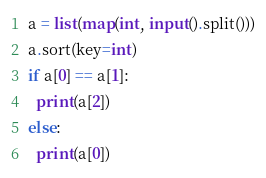<code> <loc_0><loc_0><loc_500><loc_500><_Python_>a = list(map(int, input().split()))
a.sort(key=int)
if a[0] == a[1]:
  print(a[2])
else:
  print(a[0])</code> 